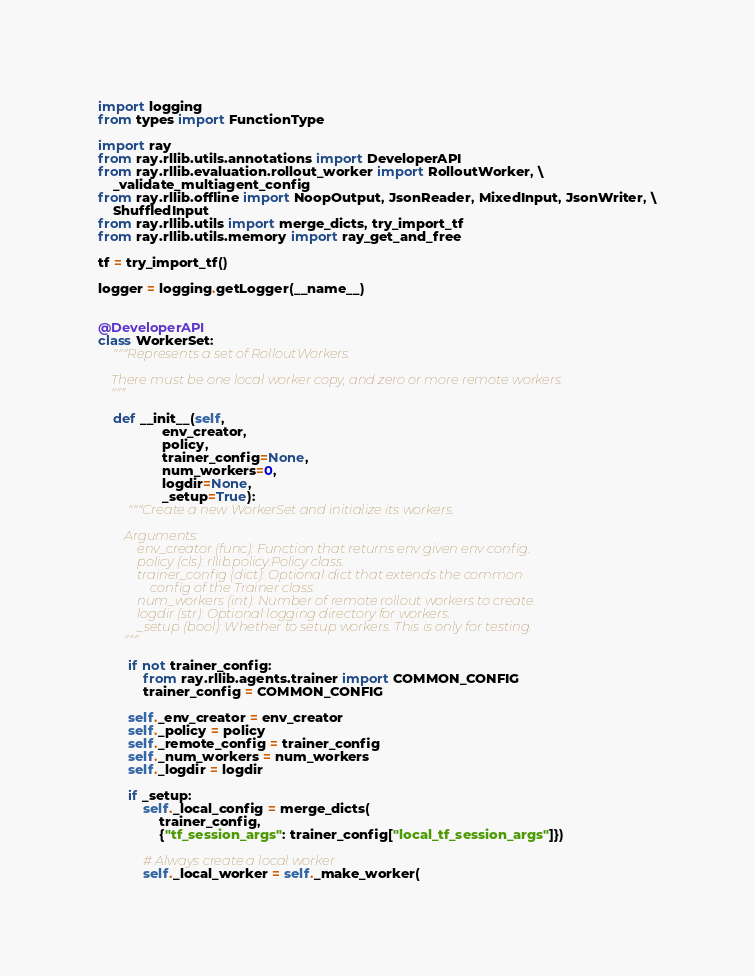<code> <loc_0><loc_0><loc_500><loc_500><_Python_>import logging
from types import FunctionType

import ray
from ray.rllib.utils.annotations import DeveloperAPI
from ray.rllib.evaluation.rollout_worker import RolloutWorker, \
    _validate_multiagent_config
from ray.rllib.offline import NoopOutput, JsonReader, MixedInput, JsonWriter, \
    ShuffledInput
from ray.rllib.utils import merge_dicts, try_import_tf
from ray.rllib.utils.memory import ray_get_and_free

tf = try_import_tf()

logger = logging.getLogger(__name__)


@DeveloperAPI
class WorkerSet:
    """Represents a set of RolloutWorkers.

    There must be one local worker copy, and zero or more remote workers.
    """

    def __init__(self,
                 env_creator,
                 policy,
                 trainer_config=None,
                 num_workers=0,
                 logdir=None,
                 _setup=True):
        """Create a new WorkerSet and initialize its workers.

        Arguments:
            env_creator (func): Function that returns env given env config.
            policy (cls): rllib.policy.Policy class.
            trainer_config (dict): Optional dict that extends the common
                config of the Trainer class.
            num_workers (int): Number of remote rollout workers to create.
            logdir (str): Optional logging directory for workers.
            _setup (bool): Whether to setup workers. This is only for testing.
        """

        if not trainer_config:
            from ray.rllib.agents.trainer import COMMON_CONFIG
            trainer_config = COMMON_CONFIG

        self._env_creator = env_creator
        self._policy = policy
        self._remote_config = trainer_config
        self._num_workers = num_workers
        self._logdir = logdir

        if _setup:
            self._local_config = merge_dicts(
                trainer_config,
                {"tf_session_args": trainer_config["local_tf_session_args"]})

            # Always create a local worker
            self._local_worker = self._make_worker(</code> 